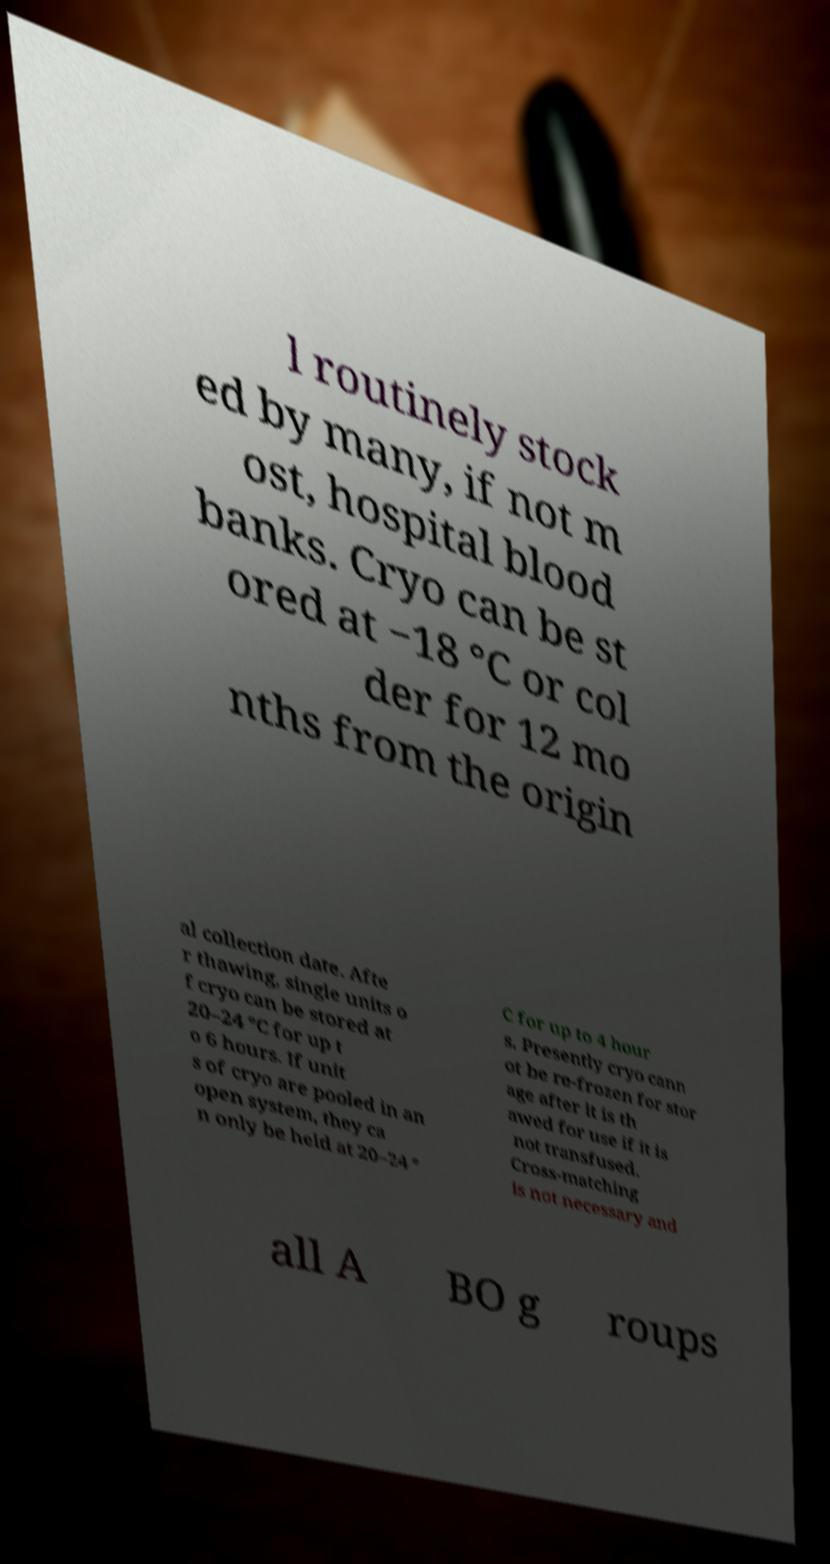Could you extract and type out the text from this image? l routinely stock ed by many, if not m ost, hospital blood banks. Cryo can be st ored at −18 °C or col der for 12 mo nths from the origin al collection date. Afte r thawing, single units o f cryo can be stored at 20–24 °C for up t o 6 hours. If unit s of cryo are pooled in an open system, they ca n only be held at 20–24 ° C for up to 4 hour s. Presently cryo cann ot be re-frozen for stor age after it is th awed for use if it is not transfused. Cross-matching is not necessary and all A BO g roups 